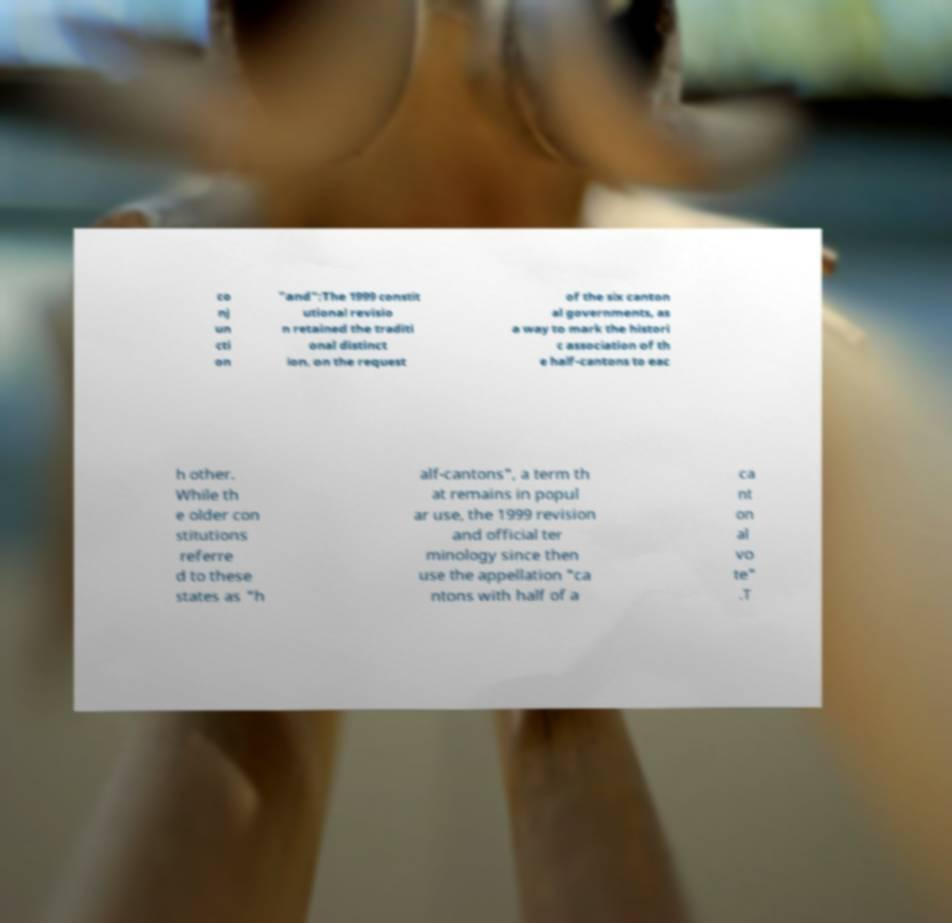There's text embedded in this image that I need extracted. Can you transcribe it verbatim? co nj un cti on "and":The 1999 constit utional revisio n retained the traditi onal distinct ion, on the request of the six canton al governments, as a way to mark the histori c association of th e half-cantons to eac h other. While th e older con stitutions referre d to these states as "h alf-cantons", a term th at remains in popul ar use, the 1999 revision and official ter minology since then use the appellation "ca ntons with half of a ca nt on al vo te" .T 